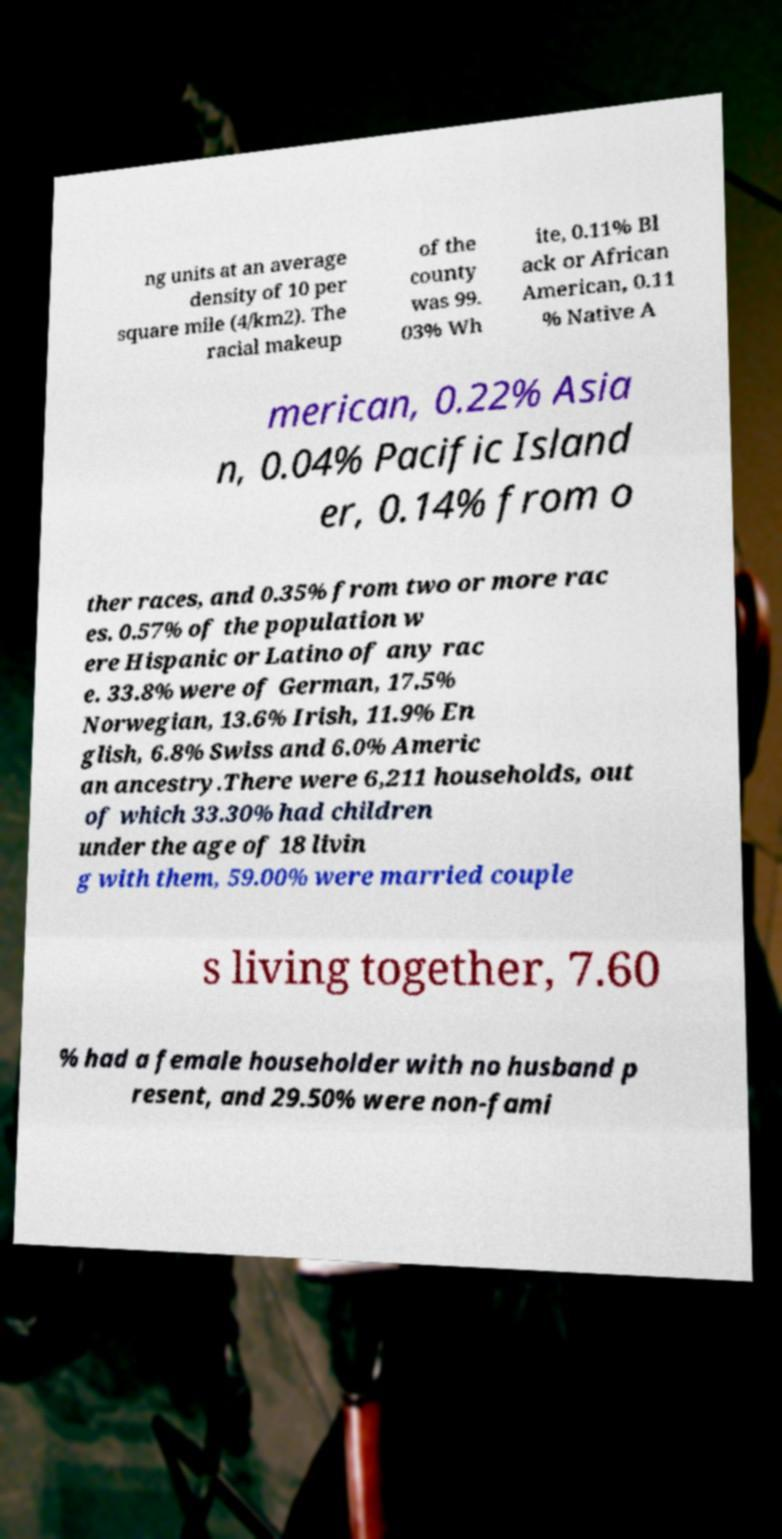What messages or text are displayed in this image? I need them in a readable, typed format. ng units at an average density of 10 per square mile (4/km2). The racial makeup of the county was 99. 03% Wh ite, 0.11% Bl ack or African American, 0.11 % Native A merican, 0.22% Asia n, 0.04% Pacific Island er, 0.14% from o ther races, and 0.35% from two or more rac es. 0.57% of the population w ere Hispanic or Latino of any rac e. 33.8% were of German, 17.5% Norwegian, 13.6% Irish, 11.9% En glish, 6.8% Swiss and 6.0% Americ an ancestry.There were 6,211 households, out of which 33.30% had children under the age of 18 livin g with them, 59.00% were married couple s living together, 7.60 % had a female householder with no husband p resent, and 29.50% were non-fami 